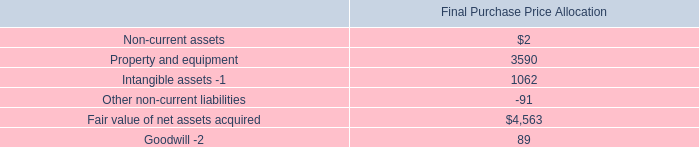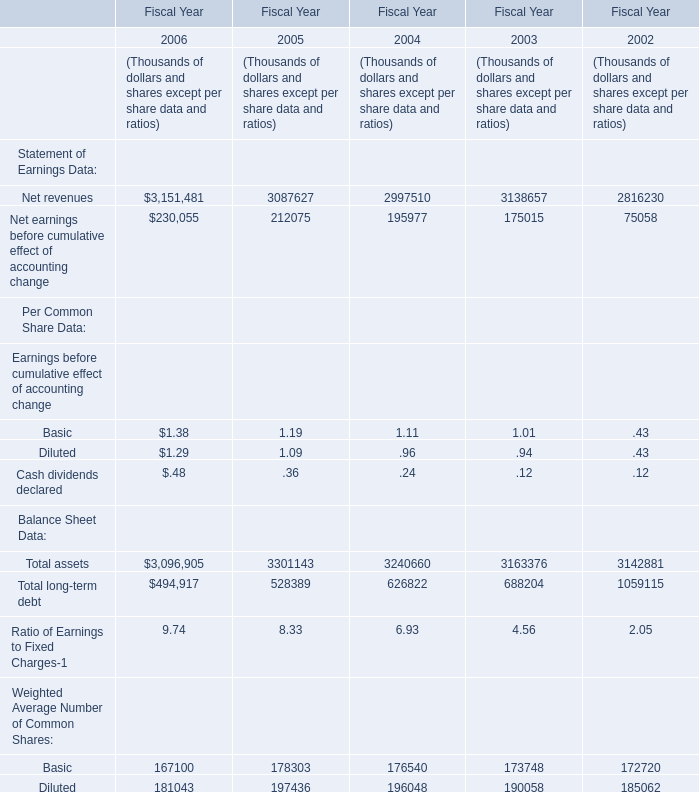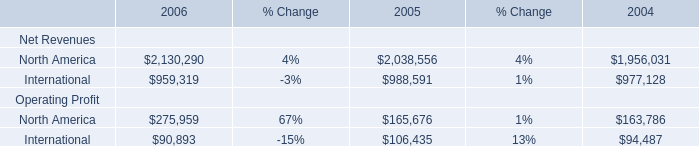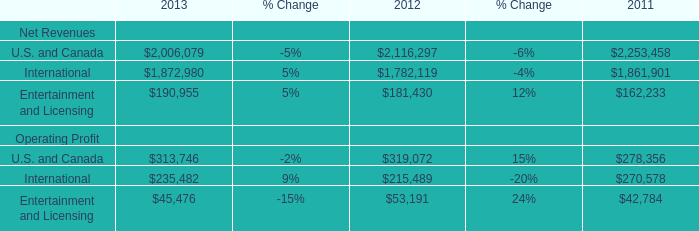What is the growth rate of Net revenues between 2005 and 2006,in terms of Fiscal Year? 
Computations: ((3151481 - 3087627) / 3087627)
Answer: 0.02068. 